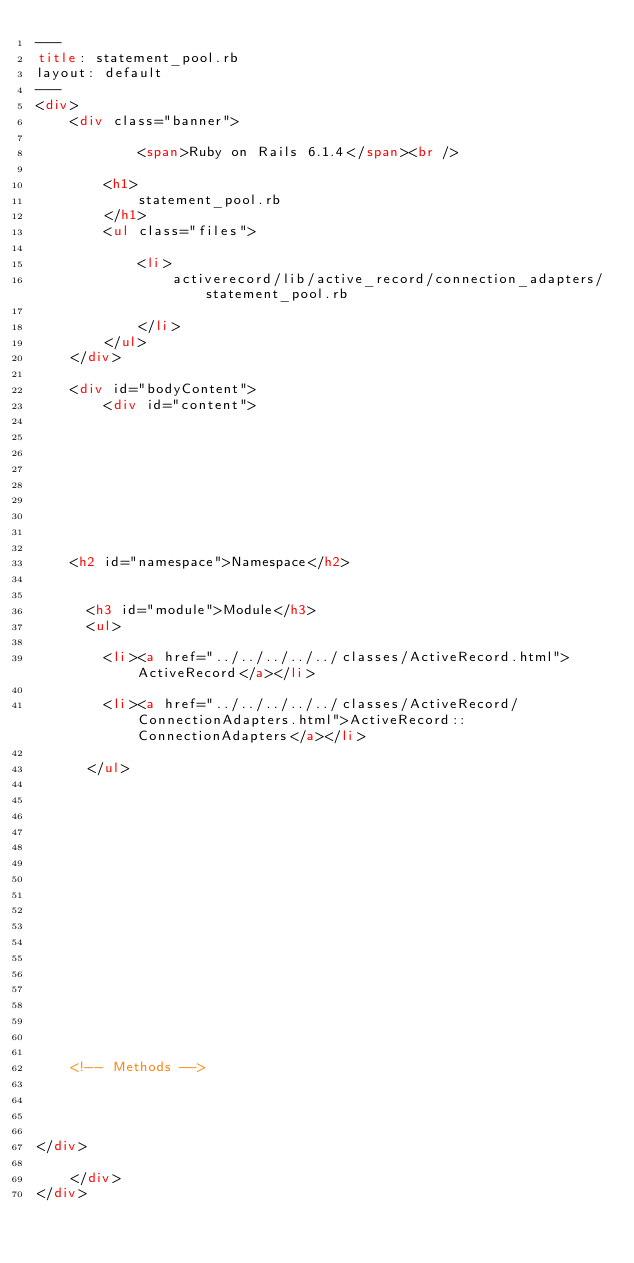<code> <loc_0><loc_0><loc_500><loc_500><_HTML_>---
title: statement_pool.rb
layout: default
---
<div>
    <div class="banner">
        
            <span>Ruby on Rails 6.1.4</span><br />
        
        <h1>
            statement_pool.rb
        </h1>
        <ul class="files">
            
            <li>
                activerecord/lib/active_record/connection_adapters/statement_pool.rb
                
            </li>
        </ul>
    </div>

    <div id="bodyContent">
        <div id="content">
  

  

  
  


  
    <h2 id="namespace">Namespace</h2>

    
      <h3 id="module">Module</h3>
      <ul>
      
        <li><a href="../../../../../classes/ActiveRecord.html">ActiveRecord</a></li>
      
        <li><a href="../../../../../classes/ActiveRecord/ConnectionAdapters.html">ActiveRecord::ConnectionAdapters</a></li>
      
      </ul>
    

    
  

  

  

  
    

    

    

    

    <!-- Methods -->
    
    
    
  
</div>

    </div>
</div>
</code> 